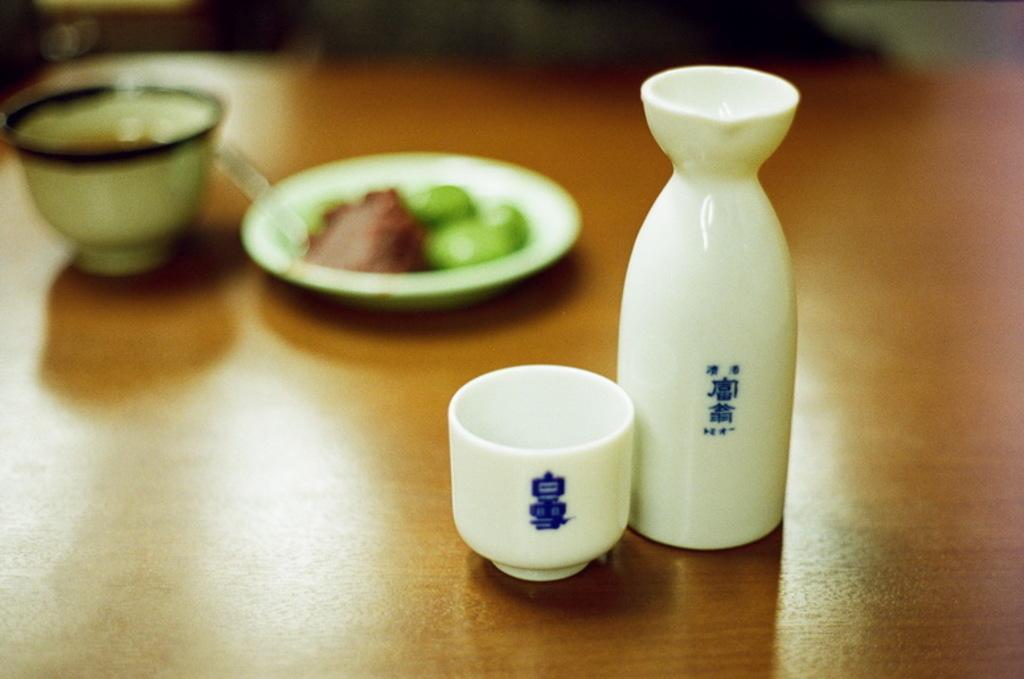Describe this image in one or two sentences. In the image there are two objects made up of ceramic and they are placed on the table, the background of these two objects is blur. 